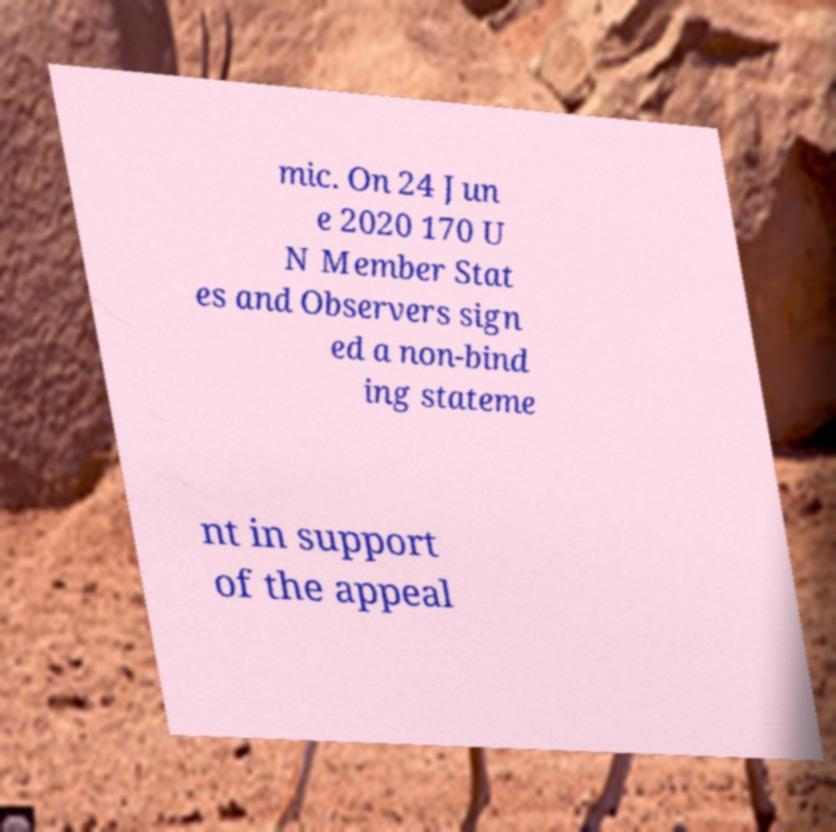Please identify and transcribe the text found in this image. mic. On 24 Jun e 2020 170 U N Member Stat es and Observers sign ed a non-bind ing stateme nt in support of the appeal 